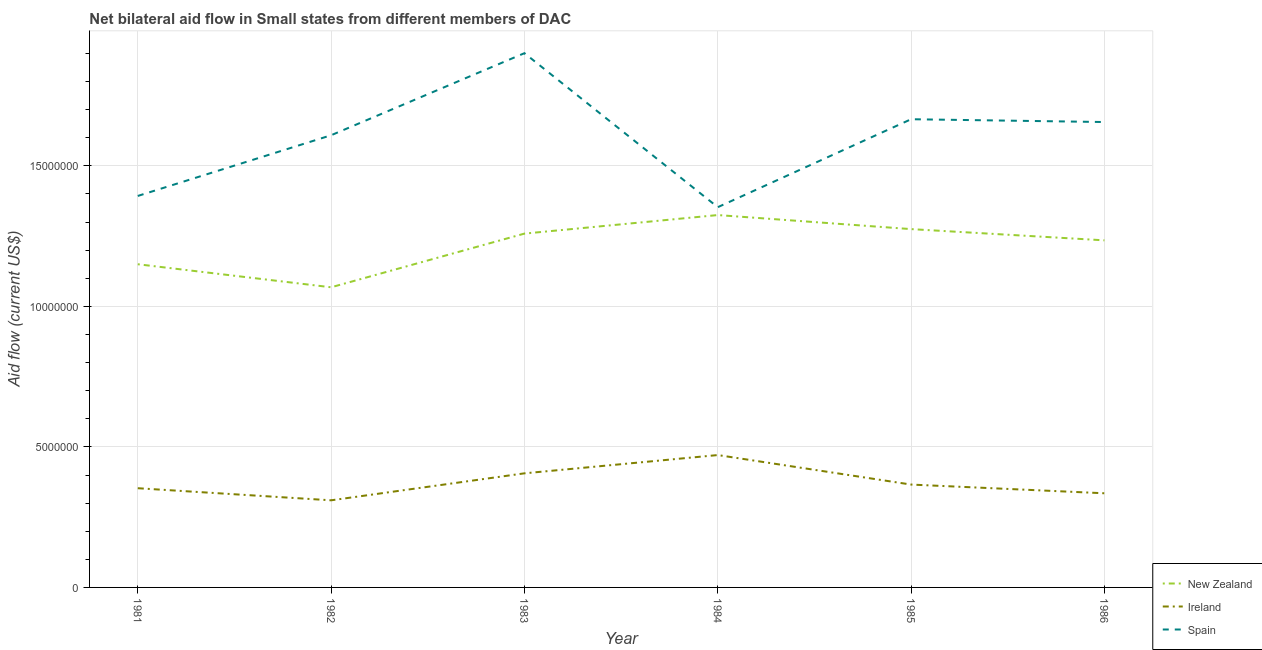Does the line corresponding to amount of aid provided by new zealand intersect with the line corresponding to amount of aid provided by spain?
Your answer should be compact. No. What is the amount of aid provided by spain in 1986?
Make the answer very short. 1.66e+07. Across all years, what is the maximum amount of aid provided by ireland?
Offer a very short reply. 4.71e+06. Across all years, what is the minimum amount of aid provided by new zealand?
Your answer should be compact. 1.07e+07. In which year was the amount of aid provided by spain minimum?
Offer a very short reply. 1984. What is the total amount of aid provided by spain in the graph?
Your response must be concise. 9.58e+07. What is the difference between the amount of aid provided by new zealand in 1982 and that in 1984?
Keep it short and to the point. -2.57e+06. What is the difference between the amount of aid provided by spain in 1983 and the amount of aid provided by new zealand in 1986?
Your answer should be very brief. 6.66e+06. What is the average amount of aid provided by spain per year?
Give a very brief answer. 1.60e+07. In the year 1983, what is the difference between the amount of aid provided by spain and amount of aid provided by new zealand?
Your answer should be very brief. 6.42e+06. In how many years, is the amount of aid provided by new zealand greater than 2000000 US$?
Offer a terse response. 6. What is the ratio of the amount of aid provided by new zealand in 1982 to that in 1985?
Provide a succinct answer. 0.84. Is the amount of aid provided by new zealand in 1983 less than that in 1984?
Offer a very short reply. Yes. Is the difference between the amount of aid provided by ireland in 1982 and 1983 greater than the difference between the amount of aid provided by new zealand in 1982 and 1983?
Make the answer very short. Yes. What is the difference between the highest and the lowest amount of aid provided by new zealand?
Keep it short and to the point. 2.57e+06. Is it the case that in every year, the sum of the amount of aid provided by new zealand and amount of aid provided by ireland is greater than the amount of aid provided by spain?
Provide a succinct answer. No. Is the amount of aid provided by new zealand strictly greater than the amount of aid provided by ireland over the years?
Your answer should be compact. Yes. How many years are there in the graph?
Offer a terse response. 6. What is the difference between two consecutive major ticks on the Y-axis?
Your answer should be compact. 5.00e+06. How are the legend labels stacked?
Give a very brief answer. Vertical. What is the title of the graph?
Your response must be concise. Net bilateral aid flow in Small states from different members of DAC. What is the label or title of the X-axis?
Your answer should be compact. Year. What is the Aid flow (current US$) of New Zealand in 1981?
Ensure brevity in your answer.  1.15e+07. What is the Aid flow (current US$) of Ireland in 1981?
Your response must be concise. 3.53e+06. What is the Aid flow (current US$) in Spain in 1981?
Offer a terse response. 1.39e+07. What is the Aid flow (current US$) of New Zealand in 1982?
Give a very brief answer. 1.07e+07. What is the Aid flow (current US$) of Ireland in 1982?
Your answer should be very brief. 3.10e+06. What is the Aid flow (current US$) in Spain in 1982?
Provide a short and direct response. 1.61e+07. What is the Aid flow (current US$) in New Zealand in 1983?
Your answer should be compact. 1.26e+07. What is the Aid flow (current US$) of Ireland in 1983?
Give a very brief answer. 4.06e+06. What is the Aid flow (current US$) of Spain in 1983?
Offer a terse response. 1.90e+07. What is the Aid flow (current US$) of New Zealand in 1984?
Give a very brief answer. 1.32e+07. What is the Aid flow (current US$) in Ireland in 1984?
Provide a succinct answer. 4.71e+06. What is the Aid flow (current US$) of Spain in 1984?
Provide a succinct answer. 1.35e+07. What is the Aid flow (current US$) of New Zealand in 1985?
Your answer should be compact. 1.28e+07. What is the Aid flow (current US$) of Ireland in 1985?
Offer a terse response. 3.66e+06. What is the Aid flow (current US$) in Spain in 1985?
Make the answer very short. 1.67e+07. What is the Aid flow (current US$) of New Zealand in 1986?
Provide a succinct answer. 1.24e+07. What is the Aid flow (current US$) in Ireland in 1986?
Provide a succinct answer. 3.35e+06. What is the Aid flow (current US$) in Spain in 1986?
Provide a short and direct response. 1.66e+07. Across all years, what is the maximum Aid flow (current US$) in New Zealand?
Your answer should be very brief. 1.32e+07. Across all years, what is the maximum Aid flow (current US$) in Ireland?
Keep it short and to the point. 4.71e+06. Across all years, what is the maximum Aid flow (current US$) of Spain?
Give a very brief answer. 1.90e+07. Across all years, what is the minimum Aid flow (current US$) in New Zealand?
Offer a terse response. 1.07e+07. Across all years, what is the minimum Aid flow (current US$) in Ireland?
Your answer should be compact. 3.10e+06. Across all years, what is the minimum Aid flow (current US$) of Spain?
Provide a succinct answer. 1.35e+07. What is the total Aid flow (current US$) in New Zealand in the graph?
Offer a very short reply. 7.31e+07. What is the total Aid flow (current US$) of Ireland in the graph?
Provide a short and direct response. 2.24e+07. What is the total Aid flow (current US$) of Spain in the graph?
Give a very brief answer. 9.58e+07. What is the difference between the Aid flow (current US$) of New Zealand in 1981 and that in 1982?
Make the answer very short. 8.20e+05. What is the difference between the Aid flow (current US$) in Ireland in 1981 and that in 1982?
Offer a very short reply. 4.30e+05. What is the difference between the Aid flow (current US$) of Spain in 1981 and that in 1982?
Your answer should be very brief. -2.16e+06. What is the difference between the Aid flow (current US$) in New Zealand in 1981 and that in 1983?
Offer a very short reply. -1.09e+06. What is the difference between the Aid flow (current US$) in Ireland in 1981 and that in 1983?
Offer a terse response. -5.30e+05. What is the difference between the Aid flow (current US$) of Spain in 1981 and that in 1983?
Provide a succinct answer. -5.08e+06. What is the difference between the Aid flow (current US$) in New Zealand in 1981 and that in 1984?
Offer a terse response. -1.75e+06. What is the difference between the Aid flow (current US$) of Ireland in 1981 and that in 1984?
Offer a very short reply. -1.18e+06. What is the difference between the Aid flow (current US$) in Spain in 1981 and that in 1984?
Offer a terse response. 4.00e+05. What is the difference between the Aid flow (current US$) in New Zealand in 1981 and that in 1985?
Give a very brief answer. -1.25e+06. What is the difference between the Aid flow (current US$) of Spain in 1981 and that in 1985?
Provide a short and direct response. -2.73e+06. What is the difference between the Aid flow (current US$) of New Zealand in 1981 and that in 1986?
Keep it short and to the point. -8.50e+05. What is the difference between the Aid flow (current US$) in Spain in 1981 and that in 1986?
Provide a succinct answer. -2.63e+06. What is the difference between the Aid flow (current US$) of New Zealand in 1982 and that in 1983?
Offer a very short reply. -1.91e+06. What is the difference between the Aid flow (current US$) in Ireland in 1982 and that in 1983?
Make the answer very short. -9.60e+05. What is the difference between the Aid flow (current US$) of Spain in 1982 and that in 1983?
Your response must be concise. -2.92e+06. What is the difference between the Aid flow (current US$) of New Zealand in 1982 and that in 1984?
Provide a succinct answer. -2.57e+06. What is the difference between the Aid flow (current US$) in Ireland in 1982 and that in 1984?
Provide a succinct answer. -1.61e+06. What is the difference between the Aid flow (current US$) in Spain in 1982 and that in 1984?
Provide a short and direct response. 2.56e+06. What is the difference between the Aid flow (current US$) of New Zealand in 1982 and that in 1985?
Provide a short and direct response. -2.07e+06. What is the difference between the Aid flow (current US$) in Ireland in 1982 and that in 1985?
Your answer should be very brief. -5.60e+05. What is the difference between the Aid flow (current US$) in Spain in 1982 and that in 1985?
Provide a short and direct response. -5.70e+05. What is the difference between the Aid flow (current US$) of New Zealand in 1982 and that in 1986?
Give a very brief answer. -1.67e+06. What is the difference between the Aid flow (current US$) in Ireland in 1982 and that in 1986?
Keep it short and to the point. -2.50e+05. What is the difference between the Aid flow (current US$) of Spain in 1982 and that in 1986?
Offer a terse response. -4.70e+05. What is the difference between the Aid flow (current US$) in New Zealand in 1983 and that in 1984?
Make the answer very short. -6.60e+05. What is the difference between the Aid flow (current US$) in Ireland in 1983 and that in 1984?
Your response must be concise. -6.50e+05. What is the difference between the Aid flow (current US$) in Spain in 1983 and that in 1984?
Give a very brief answer. 5.48e+06. What is the difference between the Aid flow (current US$) in New Zealand in 1983 and that in 1985?
Your response must be concise. -1.60e+05. What is the difference between the Aid flow (current US$) of Spain in 1983 and that in 1985?
Keep it short and to the point. 2.35e+06. What is the difference between the Aid flow (current US$) in New Zealand in 1983 and that in 1986?
Provide a short and direct response. 2.40e+05. What is the difference between the Aid flow (current US$) in Ireland in 1983 and that in 1986?
Ensure brevity in your answer.  7.10e+05. What is the difference between the Aid flow (current US$) of Spain in 1983 and that in 1986?
Provide a succinct answer. 2.45e+06. What is the difference between the Aid flow (current US$) of New Zealand in 1984 and that in 1985?
Provide a succinct answer. 5.00e+05. What is the difference between the Aid flow (current US$) in Ireland in 1984 and that in 1985?
Your response must be concise. 1.05e+06. What is the difference between the Aid flow (current US$) in Spain in 1984 and that in 1985?
Your answer should be very brief. -3.13e+06. What is the difference between the Aid flow (current US$) of New Zealand in 1984 and that in 1986?
Your response must be concise. 9.00e+05. What is the difference between the Aid flow (current US$) of Ireland in 1984 and that in 1986?
Keep it short and to the point. 1.36e+06. What is the difference between the Aid flow (current US$) of Spain in 1984 and that in 1986?
Keep it short and to the point. -3.03e+06. What is the difference between the Aid flow (current US$) of New Zealand in 1985 and that in 1986?
Provide a succinct answer. 4.00e+05. What is the difference between the Aid flow (current US$) of Ireland in 1985 and that in 1986?
Your response must be concise. 3.10e+05. What is the difference between the Aid flow (current US$) of New Zealand in 1981 and the Aid flow (current US$) of Ireland in 1982?
Your answer should be very brief. 8.40e+06. What is the difference between the Aid flow (current US$) of New Zealand in 1981 and the Aid flow (current US$) of Spain in 1982?
Provide a succinct answer. -4.59e+06. What is the difference between the Aid flow (current US$) of Ireland in 1981 and the Aid flow (current US$) of Spain in 1982?
Give a very brief answer. -1.26e+07. What is the difference between the Aid flow (current US$) in New Zealand in 1981 and the Aid flow (current US$) in Ireland in 1983?
Keep it short and to the point. 7.44e+06. What is the difference between the Aid flow (current US$) of New Zealand in 1981 and the Aid flow (current US$) of Spain in 1983?
Offer a very short reply. -7.51e+06. What is the difference between the Aid flow (current US$) of Ireland in 1981 and the Aid flow (current US$) of Spain in 1983?
Your answer should be compact. -1.55e+07. What is the difference between the Aid flow (current US$) in New Zealand in 1981 and the Aid flow (current US$) in Ireland in 1984?
Keep it short and to the point. 6.79e+06. What is the difference between the Aid flow (current US$) in New Zealand in 1981 and the Aid flow (current US$) in Spain in 1984?
Keep it short and to the point. -2.03e+06. What is the difference between the Aid flow (current US$) in Ireland in 1981 and the Aid flow (current US$) in Spain in 1984?
Offer a terse response. -1.00e+07. What is the difference between the Aid flow (current US$) in New Zealand in 1981 and the Aid flow (current US$) in Ireland in 1985?
Provide a short and direct response. 7.84e+06. What is the difference between the Aid flow (current US$) of New Zealand in 1981 and the Aid flow (current US$) of Spain in 1985?
Provide a succinct answer. -5.16e+06. What is the difference between the Aid flow (current US$) of Ireland in 1981 and the Aid flow (current US$) of Spain in 1985?
Ensure brevity in your answer.  -1.31e+07. What is the difference between the Aid flow (current US$) in New Zealand in 1981 and the Aid flow (current US$) in Ireland in 1986?
Provide a succinct answer. 8.15e+06. What is the difference between the Aid flow (current US$) in New Zealand in 1981 and the Aid flow (current US$) in Spain in 1986?
Ensure brevity in your answer.  -5.06e+06. What is the difference between the Aid flow (current US$) of Ireland in 1981 and the Aid flow (current US$) of Spain in 1986?
Give a very brief answer. -1.30e+07. What is the difference between the Aid flow (current US$) of New Zealand in 1982 and the Aid flow (current US$) of Ireland in 1983?
Provide a short and direct response. 6.62e+06. What is the difference between the Aid flow (current US$) in New Zealand in 1982 and the Aid flow (current US$) in Spain in 1983?
Keep it short and to the point. -8.33e+06. What is the difference between the Aid flow (current US$) of Ireland in 1982 and the Aid flow (current US$) of Spain in 1983?
Your response must be concise. -1.59e+07. What is the difference between the Aid flow (current US$) of New Zealand in 1982 and the Aid flow (current US$) of Ireland in 1984?
Your answer should be compact. 5.97e+06. What is the difference between the Aid flow (current US$) in New Zealand in 1982 and the Aid flow (current US$) in Spain in 1984?
Your answer should be compact. -2.85e+06. What is the difference between the Aid flow (current US$) of Ireland in 1982 and the Aid flow (current US$) of Spain in 1984?
Your answer should be compact. -1.04e+07. What is the difference between the Aid flow (current US$) in New Zealand in 1982 and the Aid flow (current US$) in Ireland in 1985?
Your answer should be compact. 7.02e+06. What is the difference between the Aid flow (current US$) of New Zealand in 1982 and the Aid flow (current US$) of Spain in 1985?
Keep it short and to the point. -5.98e+06. What is the difference between the Aid flow (current US$) of Ireland in 1982 and the Aid flow (current US$) of Spain in 1985?
Keep it short and to the point. -1.36e+07. What is the difference between the Aid flow (current US$) in New Zealand in 1982 and the Aid flow (current US$) in Ireland in 1986?
Keep it short and to the point. 7.33e+06. What is the difference between the Aid flow (current US$) of New Zealand in 1982 and the Aid flow (current US$) of Spain in 1986?
Keep it short and to the point. -5.88e+06. What is the difference between the Aid flow (current US$) of Ireland in 1982 and the Aid flow (current US$) of Spain in 1986?
Ensure brevity in your answer.  -1.35e+07. What is the difference between the Aid flow (current US$) in New Zealand in 1983 and the Aid flow (current US$) in Ireland in 1984?
Your response must be concise. 7.88e+06. What is the difference between the Aid flow (current US$) of New Zealand in 1983 and the Aid flow (current US$) of Spain in 1984?
Keep it short and to the point. -9.40e+05. What is the difference between the Aid flow (current US$) of Ireland in 1983 and the Aid flow (current US$) of Spain in 1984?
Your answer should be compact. -9.47e+06. What is the difference between the Aid flow (current US$) in New Zealand in 1983 and the Aid flow (current US$) in Ireland in 1985?
Ensure brevity in your answer.  8.93e+06. What is the difference between the Aid flow (current US$) of New Zealand in 1983 and the Aid flow (current US$) of Spain in 1985?
Your answer should be compact. -4.07e+06. What is the difference between the Aid flow (current US$) of Ireland in 1983 and the Aid flow (current US$) of Spain in 1985?
Make the answer very short. -1.26e+07. What is the difference between the Aid flow (current US$) in New Zealand in 1983 and the Aid flow (current US$) in Ireland in 1986?
Give a very brief answer. 9.24e+06. What is the difference between the Aid flow (current US$) of New Zealand in 1983 and the Aid flow (current US$) of Spain in 1986?
Ensure brevity in your answer.  -3.97e+06. What is the difference between the Aid flow (current US$) of Ireland in 1983 and the Aid flow (current US$) of Spain in 1986?
Your answer should be very brief. -1.25e+07. What is the difference between the Aid flow (current US$) in New Zealand in 1984 and the Aid flow (current US$) in Ireland in 1985?
Offer a very short reply. 9.59e+06. What is the difference between the Aid flow (current US$) of New Zealand in 1984 and the Aid flow (current US$) of Spain in 1985?
Offer a terse response. -3.41e+06. What is the difference between the Aid flow (current US$) in Ireland in 1984 and the Aid flow (current US$) in Spain in 1985?
Your answer should be compact. -1.20e+07. What is the difference between the Aid flow (current US$) of New Zealand in 1984 and the Aid flow (current US$) of Ireland in 1986?
Make the answer very short. 9.90e+06. What is the difference between the Aid flow (current US$) in New Zealand in 1984 and the Aid flow (current US$) in Spain in 1986?
Your answer should be very brief. -3.31e+06. What is the difference between the Aid flow (current US$) of Ireland in 1984 and the Aid flow (current US$) of Spain in 1986?
Make the answer very short. -1.18e+07. What is the difference between the Aid flow (current US$) in New Zealand in 1985 and the Aid flow (current US$) in Ireland in 1986?
Ensure brevity in your answer.  9.40e+06. What is the difference between the Aid flow (current US$) in New Zealand in 1985 and the Aid flow (current US$) in Spain in 1986?
Provide a succinct answer. -3.81e+06. What is the difference between the Aid flow (current US$) of Ireland in 1985 and the Aid flow (current US$) of Spain in 1986?
Your response must be concise. -1.29e+07. What is the average Aid flow (current US$) of New Zealand per year?
Keep it short and to the point. 1.22e+07. What is the average Aid flow (current US$) in Ireland per year?
Offer a terse response. 3.74e+06. What is the average Aid flow (current US$) of Spain per year?
Offer a terse response. 1.60e+07. In the year 1981, what is the difference between the Aid flow (current US$) in New Zealand and Aid flow (current US$) in Ireland?
Keep it short and to the point. 7.97e+06. In the year 1981, what is the difference between the Aid flow (current US$) in New Zealand and Aid flow (current US$) in Spain?
Your answer should be compact. -2.43e+06. In the year 1981, what is the difference between the Aid flow (current US$) of Ireland and Aid flow (current US$) of Spain?
Provide a succinct answer. -1.04e+07. In the year 1982, what is the difference between the Aid flow (current US$) of New Zealand and Aid flow (current US$) of Ireland?
Give a very brief answer. 7.58e+06. In the year 1982, what is the difference between the Aid flow (current US$) in New Zealand and Aid flow (current US$) in Spain?
Give a very brief answer. -5.41e+06. In the year 1982, what is the difference between the Aid flow (current US$) of Ireland and Aid flow (current US$) of Spain?
Offer a very short reply. -1.30e+07. In the year 1983, what is the difference between the Aid flow (current US$) in New Zealand and Aid flow (current US$) in Ireland?
Keep it short and to the point. 8.53e+06. In the year 1983, what is the difference between the Aid flow (current US$) of New Zealand and Aid flow (current US$) of Spain?
Ensure brevity in your answer.  -6.42e+06. In the year 1983, what is the difference between the Aid flow (current US$) in Ireland and Aid flow (current US$) in Spain?
Offer a terse response. -1.50e+07. In the year 1984, what is the difference between the Aid flow (current US$) of New Zealand and Aid flow (current US$) of Ireland?
Make the answer very short. 8.54e+06. In the year 1984, what is the difference between the Aid flow (current US$) of New Zealand and Aid flow (current US$) of Spain?
Your answer should be very brief. -2.80e+05. In the year 1984, what is the difference between the Aid flow (current US$) of Ireland and Aid flow (current US$) of Spain?
Give a very brief answer. -8.82e+06. In the year 1985, what is the difference between the Aid flow (current US$) in New Zealand and Aid flow (current US$) in Ireland?
Keep it short and to the point. 9.09e+06. In the year 1985, what is the difference between the Aid flow (current US$) of New Zealand and Aid flow (current US$) of Spain?
Your response must be concise. -3.91e+06. In the year 1985, what is the difference between the Aid flow (current US$) of Ireland and Aid flow (current US$) of Spain?
Offer a terse response. -1.30e+07. In the year 1986, what is the difference between the Aid flow (current US$) of New Zealand and Aid flow (current US$) of Ireland?
Provide a short and direct response. 9.00e+06. In the year 1986, what is the difference between the Aid flow (current US$) in New Zealand and Aid flow (current US$) in Spain?
Your answer should be compact. -4.21e+06. In the year 1986, what is the difference between the Aid flow (current US$) of Ireland and Aid flow (current US$) of Spain?
Your answer should be compact. -1.32e+07. What is the ratio of the Aid flow (current US$) in New Zealand in 1981 to that in 1982?
Provide a short and direct response. 1.08. What is the ratio of the Aid flow (current US$) in Ireland in 1981 to that in 1982?
Offer a terse response. 1.14. What is the ratio of the Aid flow (current US$) of Spain in 1981 to that in 1982?
Give a very brief answer. 0.87. What is the ratio of the Aid flow (current US$) in New Zealand in 1981 to that in 1983?
Provide a succinct answer. 0.91. What is the ratio of the Aid flow (current US$) in Ireland in 1981 to that in 1983?
Provide a succinct answer. 0.87. What is the ratio of the Aid flow (current US$) of Spain in 1981 to that in 1983?
Provide a succinct answer. 0.73. What is the ratio of the Aid flow (current US$) of New Zealand in 1981 to that in 1984?
Provide a succinct answer. 0.87. What is the ratio of the Aid flow (current US$) in Ireland in 1981 to that in 1984?
Provide a short and direct response. 0.75. What is the ratio of the Aid flow (current US$) of Spain in 1981 to that in 1984?
Ensure brevity in your answer.  1.03. What is the ratio of the Aid flow (current US$) of New Zealand in 1981 to that in 1985?
Your response must be concise. 0.9. What is the ratio of the Aid flow (current US$) in Ireland in 1981 to that in 1985?
Provide a short and direct response. 0.96. What is the ratio of the Aid flow (current US$) in Spain in 1981 to that in 1985?
Give a very brief answer. 0.84. What is the ratio of the Aid flow (current US$) of New Zealand in 1981 to that in 1986?
Ensure brevity in your answer.  0.93. What is the ratio of the Aid flow (current US$) in Ireland in 1981 to that in 1986?
Provide a succinct answer. 1.05. What is the ratio of the Aid flow (current US$) of Spain in 1981 to that in 1986?
Provide a succinct answer. 0.84. What is the ratio of the Aid flow (current US$) in New Zealand in 1982 to that in 1983?
Your answer should be compact. 0.85. What is the ratio of the Aid flow (current US$) of Ireland in 1982 to that in 1983?
Offer a very short reply. 0.76. What is the ratio of the Aid flow (current US$) of Spain in 1982 to that in 1983?
Your response must be concise. 0.85. What is the ratio of the Aid flow (current US$) of New Zealand in 1982 to that in 1984?
Make the answer very short. 0.81. What is the ratio of the Aid flow (current US$) of Ireland in 1982 to that in 1984?
Ensure brevity in your answer.  0.66. What is the ratio of the Aid flow (current US$) of Spain in 1982 to that in 1984?
Offer a very short reply. 1.19. What is the ratio of the Aid flow (current US$) in New Zealand in 1982 to that in 1985?
Offer a terse response. 0.84. What is the ratio of the Aid flow (current US$) of Ireland in 1982 to that in 1985?
Provide a succinct answer. 0.85. What is the ratio of the Aid flow (current US$) in Spain in 1982 to that in 1985?
Ensure brevity in your answer.  0.97. What is the ratio of the Aid flow (current US$) in New Zealand in 1982 to that in 1986?
Your response must be concise. 0.86. What is the ratio of the Aid flow (current US$) in Ireland in 1982 to that in 1986?
Ensure brevity in your answer.  0.93. What is the ratio of the Aid flow (current US$) of Spain in 1982 to that in 1986?
Give a very brief answer. 0.97. What is the ratio of the Aid flow (current US$) of New Zealand in 1983 to that in 1984?
Your response must be concise. 0.95. What is the ratio of the Aid flow (current US$) in Ireland in 1983 to that in 1984?
Offer a terse response. 0.86. What is the ratio of the Aid flow (current US$) in Spain in 1983 to that in 1984?
Offer a terse response. 1.41. What is the ratio of the Aid flow (current US$) of New Zealand in 1983 to that in 1985?
Give a very brief answer. 0.99. What is the ratio of the Aid flow (current US$) in Ireland in 1983 to that in 1985?
Your answer should be compact. 1.11. What is the ratio of the Aid flow (current US$) in Spain in 1983 to that in 1985?
Provide a short and direct response. 1.14. What is the ratio of the Aid flow (current US$) in New Zealand in 1983 to that in 1986?
Provide a succinct answer. 1.02. What is the ratio of the Aid flow (current US$) in Ireland in 1983 to that in 1986?
Give a very brief answer. 1.21. What is the ratio of the Aid flow (current US$) of Spain in 1983 to that in 1986?
Make the answer very short. 1.15. What is the ratio of the Aid flow (current US$) of New Zealand in 1984 to that in 1985?
Your response must be concise. 1.04. What is the ratio of the Aid flow (current US$) of Ireland in 1984 to that in 1985?
Make the answer very short. 1.29. What is the ratio of the Aid flow (current US$) in Spain in 1984 to that in 1985?
Your response must be concise. 0.81. What is the ratio of the Aid flow (current US$) of New Zealand in 1984 to that in 1986?
Your answer should be very brief. 1.07. What is the ratio of the Aid flow (current US$) in Ireland in 1984 to that in 1986?
Your answer should be very brief. 1.41. What is the ratio of the Aid flow (current US$) in Spain in 1984 to that in 1986?
Your answer should be very brief. 0.82. What is the ratio of the Aid flow (current US$) in New Zealand in 1985 to that in 1986?
Offer a very short reply. 1.03. What is the ratio of the Aid flow (current US$) in Ireland in 1985 to that in 1986?
Keep it short and to the point. 1.09. What is the difference between the highest and the second highest Aid flow (current US$) in New Zealand?
Your answer should be compact. 5.00e+05. What is the difference between the highest and the second highest Aid flow (current US$) of Ireland?
Provide a short and direct response. 6.50e+05. What is the difference between the highest and the second highest Aid flow (current US$) in Spain?
Provide a succinct answer. 2.35e+06. What is the difference between the highest and the lowest Aid flow (current US$) in New Zealand?
Offer a terse response. 2.57e+06. What is the difference between the highest and the lowest Aid flow (current US$) in Ireland?
Your answer should be very brief. 1.61e+06. What is the difference between the highest and the lowest Aid flow (current US$) of Spain?
Provide a succinct answer. 5.48e+06. 